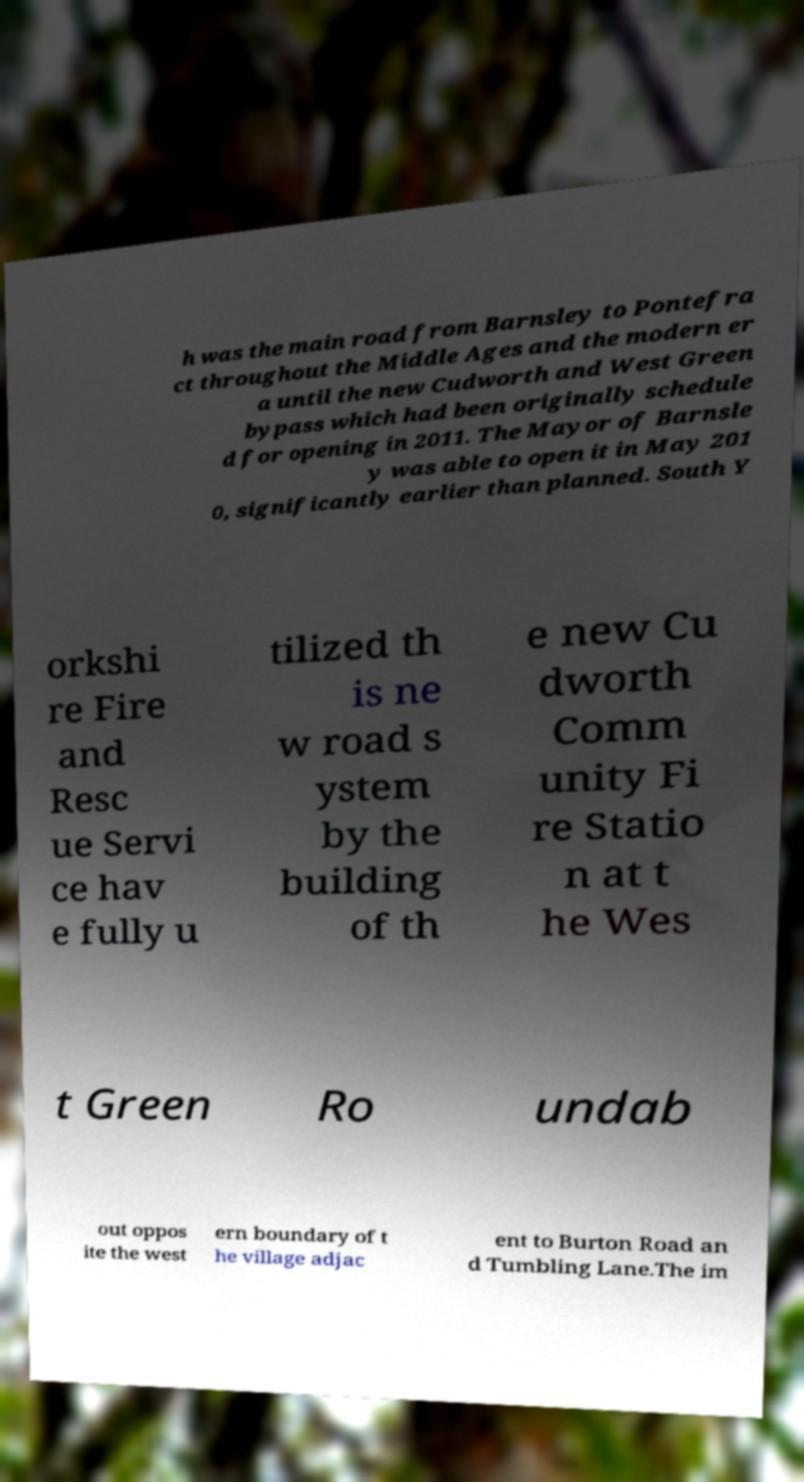Please read and relay the text visible in this image. What does it say? h was the main road from Barnsley to Pontefra ct throughout the Middle Ages and the modern er a until the new Cudworth and West Green bypass which had been originally schedule d for opening in 2011. The Mayor of Barnsle y was able to open it in May 201 0, significantly earlier than planned. South Y orkshi re Fire and Resc ue Servi ce hav e fully u tilized th is ne w road s ystem by the building of th e new Cu dworth Comm unity Fi re Statio n at t he Wes t Green Ro undab out oppos ite the west ern boundary of t he village adjac ent to Burton Road an d Tumbling Lane.The im 